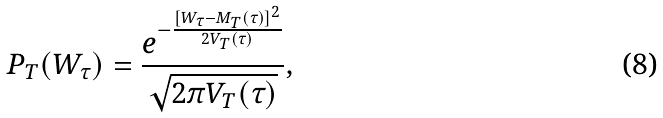Convert formula to latex. <formula><loc_0><loc_0><loc_500><loc_500>P _ { T } ( W _ { \tau } ) = \frac { e ^ { - \frac { [ W _ { \tau } - M _ { T } ( \tau ) ] ^ { 2 } } { 2 V _ { T } ( \tau ) } } } { \sqrt { 2 \pi V _ { T } ( \tau ) } } ,</formula> 